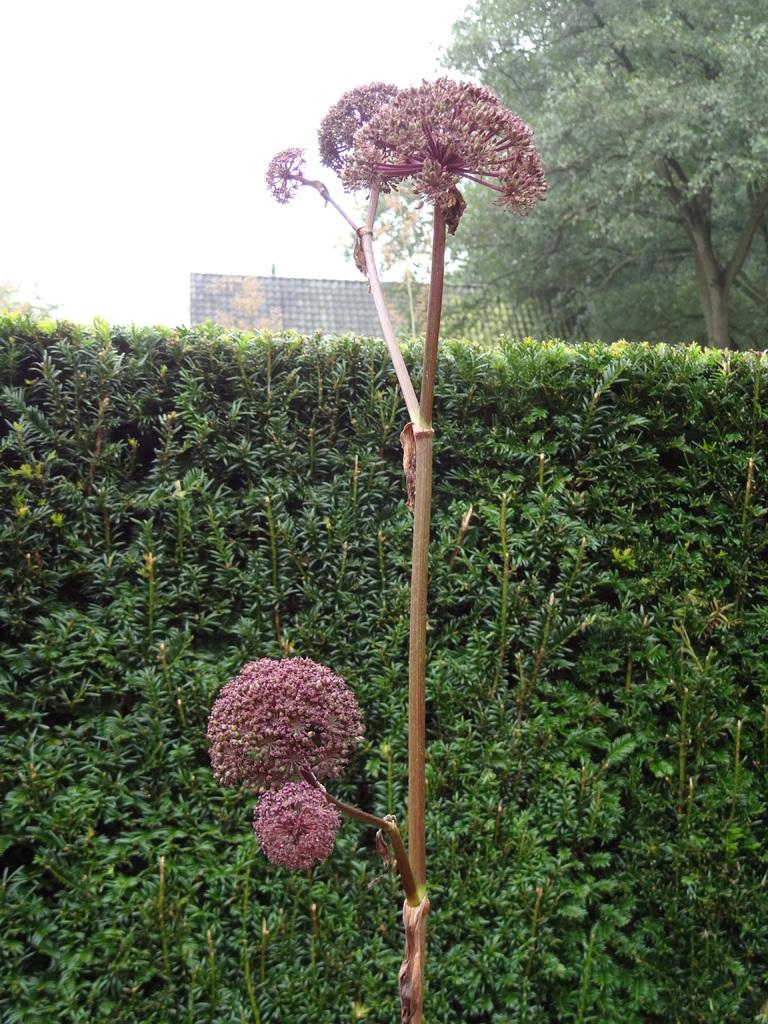What type of plant can be seen in the image? There is a plant with flowers in the image. What other vegetation is present in the image? There are trees in the image. What can be seen in the background of the image? There is an object that looks like a wall in the background, and the sky is also visible. What type of vest is the plant wearing in the image? There is no vest present in the image, as plants do not wear clothing. 